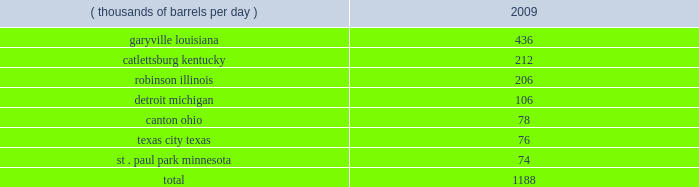Technical and research personnel and lab facilities , and significantly expanded the portfolio of patents available to us via license and through a cooperative development program .
In addition , we have acquired a 20 percent interest in grt , inc .
The gtftm technology is protected by an intellectual property protection program .
The u.s .
Has granted 17 patents for the technology , with another 22 pending .
Worldwide , there are over 300 patents issued or pending , covering over 100 countries including regional and direct foreign filings .
Another innovative technology that we are developing focuses on reducing the processing and transportation costs of natural gas by artificially creating natural gas hydrates , which are more easily transportable than natural gas in its gaseous form .
Much like lng , gas hydrates would then be regasified upon delivery to the receiving market .
We have an active pilot program in place to test and further develop a proprietary natural gas hydrates manufacturing system .
The above discussion of the integrated gas segment contains forward-looking statements with respect to the possible expansion of the lng production facility .
Factors that could potentially affect the possible expansion of the lng production facility include partner and government approvals , access to sufficient natural gas volumes through exploration or commercial negotiations with other resource owners and access to sufficient regasification capacity .
The foregoing factors ( among others ) could cause actual results to differ materially from those set forth in the forward-looking statements .
Refining , marketing and transportation we have refining , marketing and transportation operations concentrated primarily in the midwest , upper great plains , gulf coast and southeast regions of the u.s .
We rank as the fifth largest crude oil refiner in the u.s .
And the largest in the midwest .
Our operations include a seven-plant refining network and an integrated terminal and transportation system which supplies wholesale and marathon-brand customers as well as our own retail operations .
Our wholly-owned retail marketing subsidiary speedway superamerica llc ( 201cssa 201d ) is the third largest chain of company-owned and -operated retail gasoline and convenience stores in the u.s .
And the largest in the midwest .
Refining we own and operate seven refineries with an aggregate refining capacity of 1.188 million barrels per day ( 201cmmbpd 201d ) of crude oil as of december 31 , 2009 .
During 2009 , our refineries processed 957 mbpd of crude oil and 196 mbpd of other charge and blend stocks .
The table below sets forth the location and daily crude oil refining capacity of each of our refineries as of december 31 , 2009 .
Crude oil refining capacity ( thousands of barrels per day ) 2009 .
Our refineries include crude oil atmospheric and vacuum distillation , fluid catalytic cracking , catalytic reforming , desulfurization and sulfur recovery units .
The refineries process a wide variety of crude oils and produce numerous refined products , ranging from transportation fuels , such as reformulated gasolines , blend- grade gasolines intended for blending with fuel ethanol and ultra-low sulfur diesel fuel , to heavy fuel oil and asphalt .
Additionally , we manufacture aromatics , cumene , propane , propylene , sulfur and maleic anhydride .
Our garyville , louisiana , refinery is located along the mississippi river in southeastern louisiana between new orleans and baton rouge .
The garyville refinery predominantly processes heavy sour crude oil into products .
What percentage of crude oil refining capacity is located in garyville louisiana? 
Computations: (436 / 1188)
Answer: 0.367. 